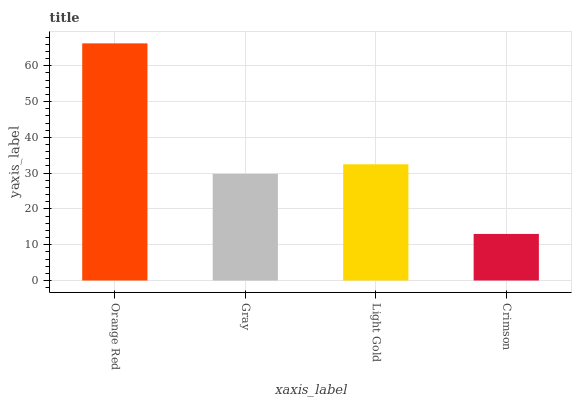Is Gray the minimum?
Answer yes or no. No. Is Gray the maximum?
Answer yes or no. No. Is Orange Red greater than Gray?
Answer yes or no. Yes. Is Gray less than Orange Red?
Answer yes or no. Yes. Is Gray greater than Orange Red?
Answer yes or no. No. Is Orange Red less than Gray?
Answer yes or no. No. Is Light Gold the high median?
Answer yes or no. Yes. Is Gray the low median?
Answer yes or no. Yes. Is Gray the high median?
Answer yes or no. No. Is Light Gold the low median?
Answer yes or no. No. 